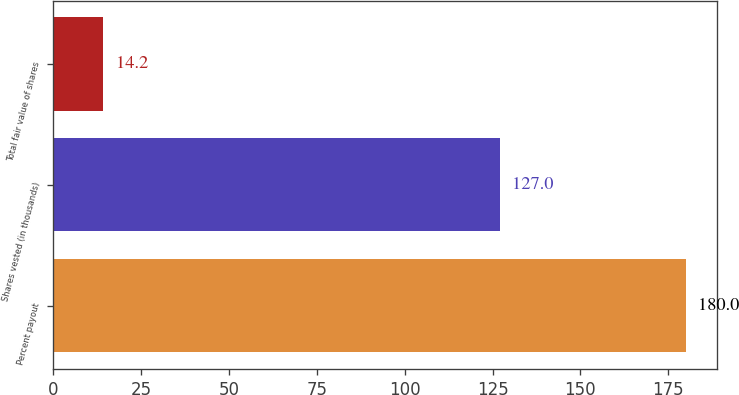Convert chart to OTSL. <chart><loc_0><loc_0><loc_500><loc_500><bar_chart><fcel>Percent payout<fcel>Shares vested (in thousands)<fcel>Total fair value of shares<nl><fcel>180<fcel>127<fcel>14.2<nl></chart> 